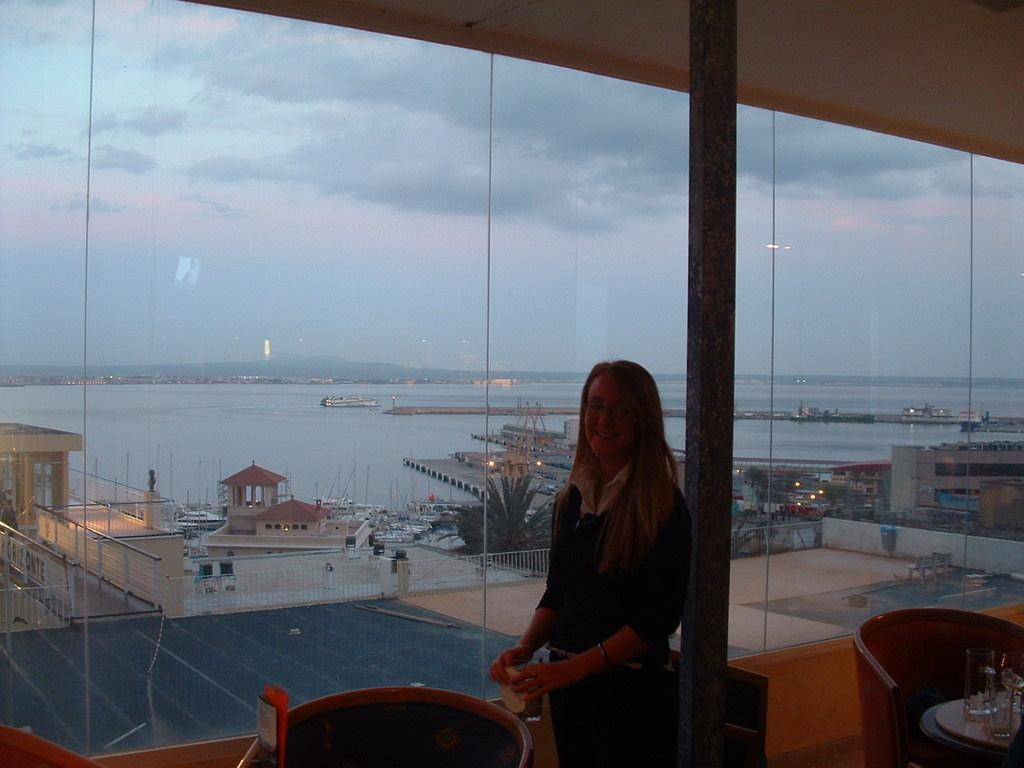Who is present in the image? There is a woman in the image. What is the woman wearing? The woman is wearing a black dress. What is the woman doing in the image? The woman is standing. What can be seen in the background of the image? There are buildings, a port, and a river in the background of the image. What type of pie is the woman holding in the image? There is no pie present in the image; the woman is not holding anything. 